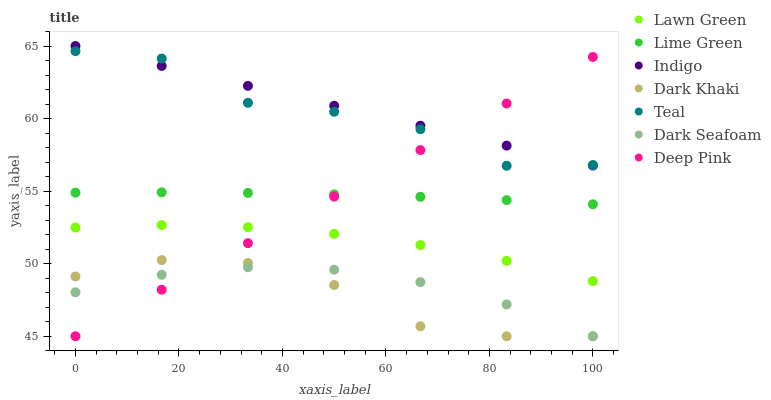Does Dark Khaki have the minimum area under the curve?
Answer yes or no. Yes. Does Indigo have the maximum area under the curve?
Answer yes or no. Yes. Does Deep Pink have the minimum area under the curve?
Answer yes or no. No. Does Deep Pink have the maximum area under the curve?
Answer yes or no. No. Is Indigo the smoothest?
Answer yes or no. Yes. Is Teal the roughest?
Answer yes or no. Yes. Is Deep Pink the smoothest?
Answer yes or no. No. Is Deep Pink the roughest?
Answer yes or no. No. Does Deep Pink have the lowest value?
Answer yes or no. Yes. Does Indigo have the lowest value?
Answer yes or no. No. Does Indigo have the highest value?
Answer yes or no. Yes. Does Deep Pink have the highest value?
Answer yes or no. No. Is Dark Seafoam less than Lime Green?
Answer yes or no. Yes. Is Teal greater than Dark Khaki?
Answer yes or no. Yes. Does Lawn Green intersect Deep Pink?
Answer yes or no. Yes. Is Lawn Green less than Deep Pink?
Answer yes or no. No. Is Lawn Green greater than Deep Pink?
Answer yes or no. No. Does Dark Seafoam intersect Lime Green?
Answer yes or no. No. 